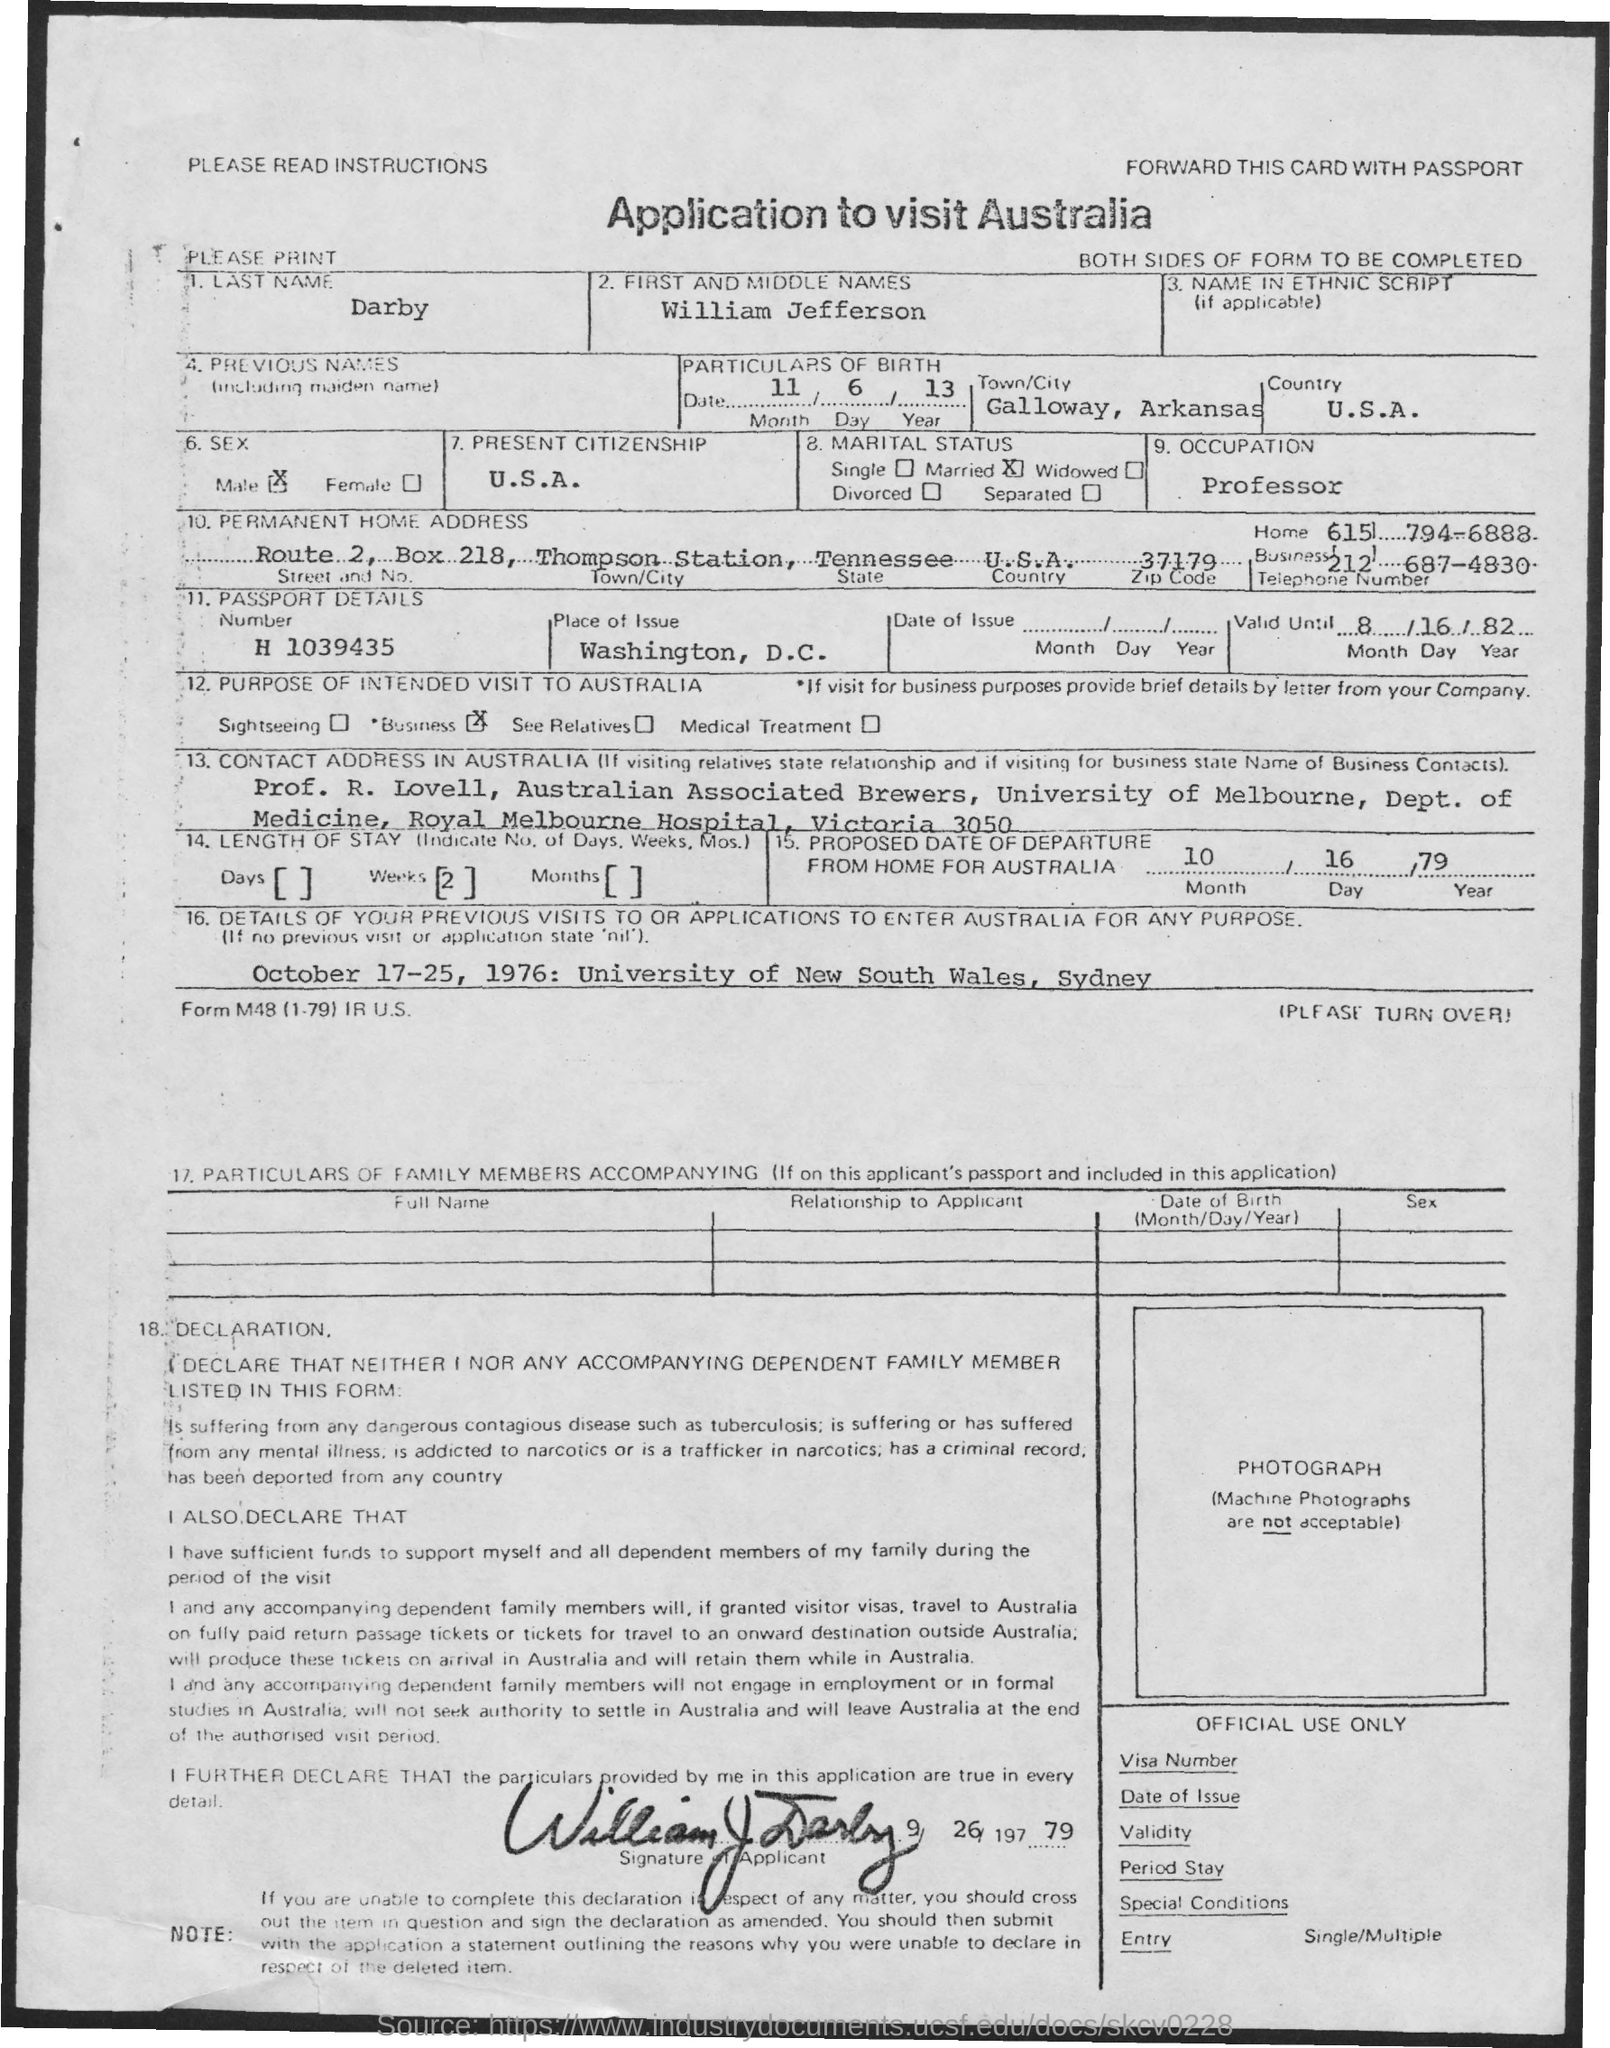What is the given document related to??
Your answer should be compact. Application to visit Australia. What is the occupation of the applicant william?
Your answer should be compact. Professor. 